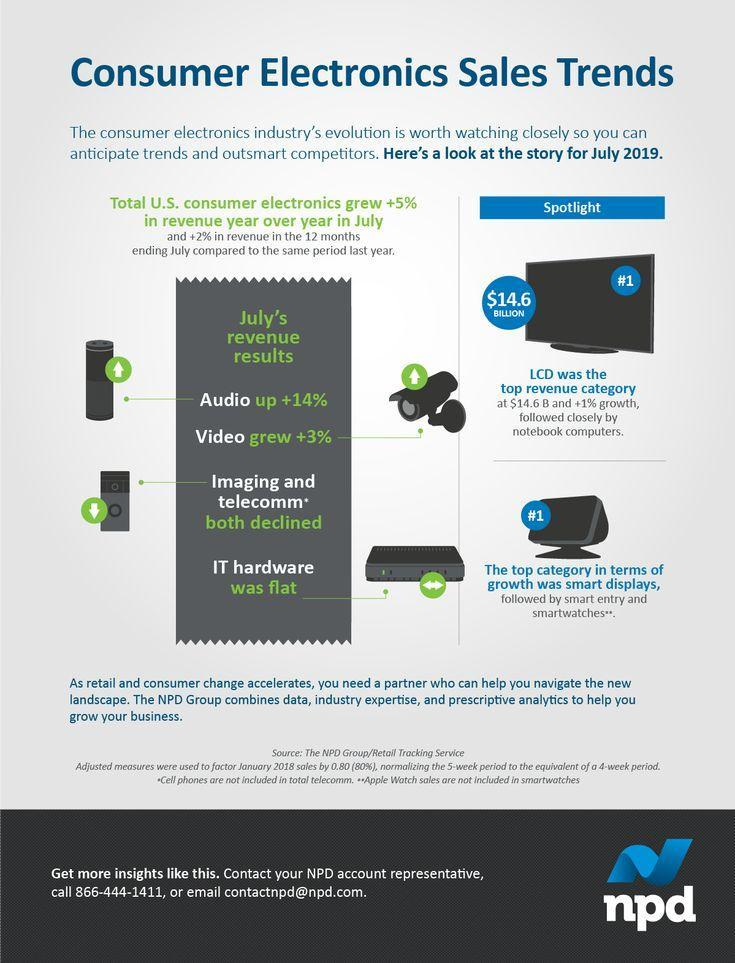Which device registered the highest growth in Electronics, Imaging and Telecommunication devices, Notebooks, or LCD televisions?
Answer the question with a short phrase. LCD televisions Which are the three top categories in smart devices? smart displays, smart entry, smart watches 